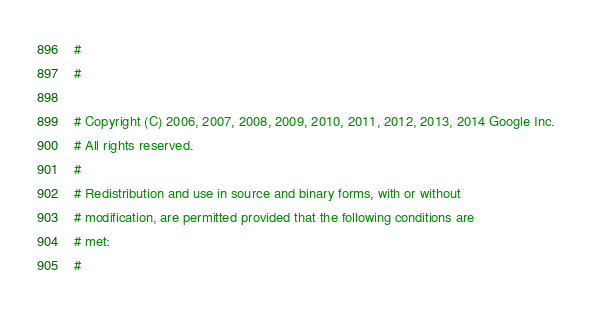<code> <loc_0><loc_0><loc_500><loc_500><_Python_>#
#

# Copyright (C) 2006, 2007, 2008, 2009, 2010, 2011, 2012, 2013, 2014 Google Inc.
# All rights reserved.
#
# Redistribution and use in source and binary forms, with or without
# modification, are permitted provided that the following conditions are
# met:
#</code> 